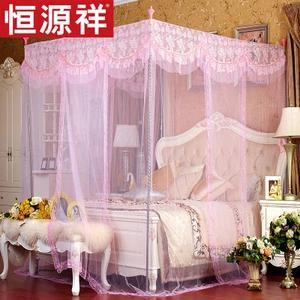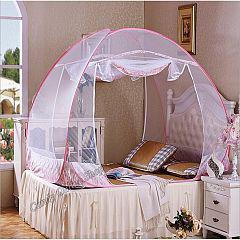The first image is the image on the left, the second image is the image on the right. Considering the images on both sides, is "All bed canopies are the same shape as the bed with a deep ruffle at the top and sheer curtains draping down." valid? Answer yes or no. No. The first image is the image on the left, the second image is the image on the right. Analyze the images presented: Is the assertion "The bed in one of the images is surrounded by purple netting" valid? Answer yes or no. No. 